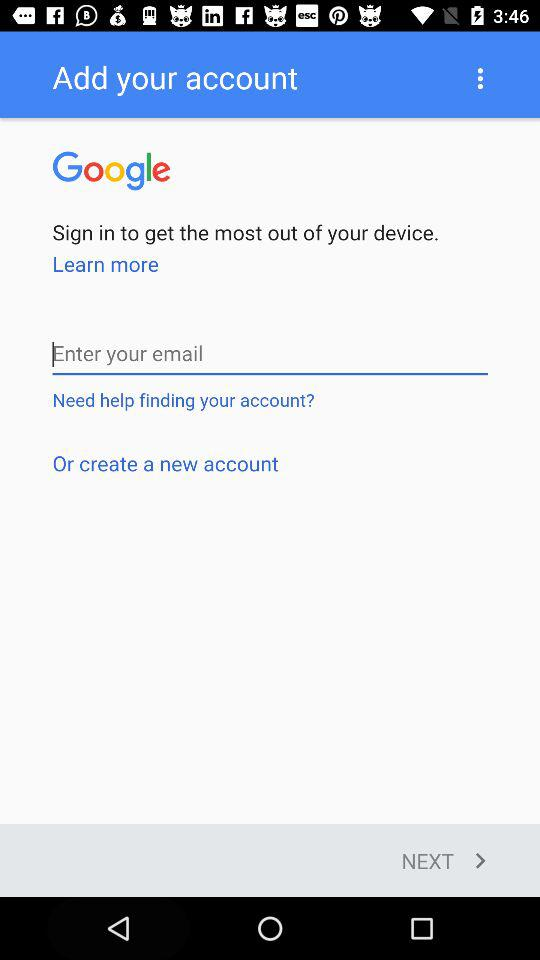What is the application name? The application name is "Google". 